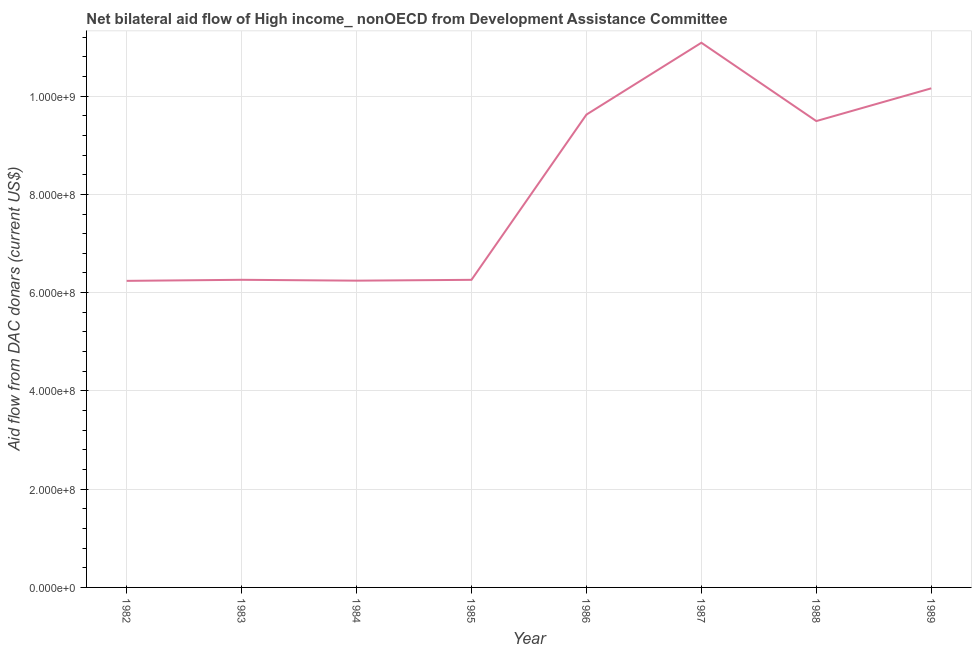What is the net bilateral aid flows from dac donors in 1988?
Give a very brief answer. 9.49e+08. Across all years, what is the maximum net bilateral aid flows from dac donors?
Provide a succinct answer. 1.11e+09. Across all years, what is the minimum net bilateral aid flows from dac donors?
Offer a very short reply. 6.24e+08. In which year was the net bilateral aid flows from dac donors maximum?
Your response must be concise. 1987. In which year was the net bilateral aid flows from dac donors minimum?
Offer a very short reply. 1982. What is the sum of the net bilateral aid flows from dac donors?
Your answer should be compact. 6.54e+09. What is the difference between the net bilateral aid flows from dac donors in 1986 and 1987?
Keep it short and to the point. -1.46e+08. What is the average net bilateral aid flows from dac donors per year?
Your response must be concise. 8.17e+08. What is the median net bilateral aid flows from dac donors?
Ensure brevity in your answer.  7.88e+08. What is the ratio of the net bilateral aid flows from dac donors in 1988 to that in 1989?
Provide a succinct answer. 0.93. Is the net bilateral aid flows from dac donors in 1982 less than that in 1983?
Your response must be concise. Yes. Is the difference between the net bilateral aid flows from dac donors in 1982 and 1989 greater than the difference between any two years?
Give a very brief answer. No. What is the difference between the highest and the second highest net bilateral aid flows from dac donors?
Offer a terse response. 9.28e+07. What is the difference between the highest and the lowest net bilateral aid flows from dac donors?
Give a very brief answer. 4.85e+08. In how many years, is the net bilateral aid flows from dac donors greater than the average net bilateral aid flows from dac donors taken over all years?
Your response must be concise. 4. How many years are there in the graph?
Provide a succinct answer. 8. What is the difference between two consecutive major ticks on the Y-axis?
Provide a short and direct response. 2.00e+08. Does the graph contain any zero values?
Keep it short and to the point. No. What is the title of the graph?
Ensure brevity in your answer.  Net bilateral aid flow of High income_ nonOECD from Development Assistance Committee. What is the label or title of the X-axis?
Your response must be concise. Year. What is the label or title of the Y-axis?
Ensure brevity in your answer.  Aid flow from DAC donars (current US$). What is the Aid flow from DAC donars (current US$) in 1982?
Make the answer very short. 6.24e+08. What is the Aid flow from DAC donars (current US$) of 1983?
Give a very brief answer. 6.26e+08. What is the Aid flow from DAC donars (current US$) of 1984?
Offer a very short reply. 6.24e+08. What is the Aid flow from DAC donars (current US$) in 1985?
Provide a succinct answer. 6.26e+08. What is the Aid flow from DAC donars (current US$) of 1986?
Keep it short and to the point. 9.62e+08. What is the Aid flow from DAC donars (current US$) of 1987?
Provide a short and direct response. 1.11e+09. What is the Aid flow from DAC donars (current US$) of 1988?
Provide a short and direct response. 9.49e+08. What is the Aid flow from DAC donars (current US$) in 1989?
Provide a short and direct response. 1.02e+09. What is the difference between the Aid flow from DAC donars (current US$) in 1982 and 1983?
Make the answer very short. -2.17e+06. What is the difference between the Aid flow from DAC donars (current US$) in 1982 and 1984?
Your response must be concise. -4.10e+05. What is the difference between the Aid flow from DAC donars (current US$) in 1982 and 1985?
Provide a succinct answer. -2.11e+06. What is the difference between the Aid flow from DAC donars (current US$) in 1982 and 1986?
Make the answer very short. -3.38e+08. What is the difference between the Aid flow from DAC donars (current US$) in 1982 and 1987?
Make the answer very short. -4.85e+08. What is the difference between the Aid flow from DAC donars (current US$) in 1982 and 1988?
Your answer should be compact. -3.25e+08. What is the difference between the Aid flow from DAC donars (current US$) in 1982 and 1989?
Provide a short and direct response. -3.92e+08. What is the difference between the Aid flow from DAC donars (current US$) in 1983 and 1984?
Your answer should be very brief. 1.76e+06. What is the difference between the Aid flow from DAC donars (current US$) in 1983 and 1986?
Your answer should be very brief. -3.36e+08. What is the difference between the Aid flow from DAC donars (current US$) in 1983 and 1987?
Your answer should be compact. -4.83e+08. What is the difference between the Aid flow from DAC donars (current US$) in 1983 and 1988?
Offer a terse response. -3.23e+08. What is the difference between the Aid flow from DAC donars (current US$) in 1983 and 1989?
Your answer should be very brief. -3.90e+08. What is the difference between the Aid flow from DAC donars (current US$) in 1984 and 1985?
Ensure brevity in your answer.  -1.70e+06. What is the difference between the Aid flow from DAC donars (current US$) in 1984 and 1986?
Offer a very short reply. -3.38e+08. What is the difference between the Aid flow from DAC donars (current US$) in 1984 and 1987?
Offer a very short reply. -4.84e+08. What is the difference between the Aid flow from DAC donars (current US$) in 1984 and 1988?
Provide a succinct answer. -3.25e+08. What is the difference between the Aid flow from DAC donars (current US$) in 1984 and 1989?
Provide a succinct answer. -3.91e+08. What is the difference between the Aid flow from DAC donars (current US$) in 1985 and 1986?
Offer a terse response. -3.36e+08. What is the difference between the Aid flow from DAC donars (current US$) in 1985 and 1987?
Provide a short and direct response. -4.83e+08. What is the difference between the Aid flow from DAC donars (current US$) in 1985 and 1988?
Offer a very short reply. -3.23e+08. What is the difference between the Aid flow from DAC donars (current US$) in 1985 and 1989?
Your answer should be compact. -3.90e+08. What is the difference between the Aid flow from DAC donars (current US$) in 1986 and 1987?
Your answer should be very brief. -1.46e+08. What is the difference between the Aid flow from DAC donars (current US$) in 1986 and 1988?
Your answer should be very brief. 1.32e+07. What is the difference between the Aid flow from DAC donars (current US$) in 1986 and 1989?
Your answer should be very brief. -5.35e+07. What is the difference between the Aid flow from DAC donars (current US$) in 1987 and 1988?
Provide a succinct answer. 1.59e+08. What is the difference between the Aid flow from DAC donars (current US$) in 1987 and 1989?
Your answer should be very brief. 9.28e+07. What is the difference between the Aid flow from DAC donars (current US$) in 1988 and 1989?
Your answer should be compact. -6.66e+07. What is the ratio of the Aid flow from DAC donars (current US$) in 1982 to that in 1983?
Your answer should be compact. 1. What is the ratio of the Aid flow from DAC donars (current US$) in 1982 to that in 1984?
Give a very brief answer. 1. What is the ratio of the Aid flow from DAC donars (current US$) in 1982 to that in 1986?
Offer a terse response. 0.65. What is the ratio of the Aid flow from DAC donars (current US$) in 1982 to that in 1987?
Your answer should be very brief. 0.56. What is the ratio of the Aid flow from DAC donars (current US$) in 1982 to that in 1988?
Offer a very short reply. 0.66. What is the ratio of the Aid flow from DAC donars (current US$) in 1982 to that in 1989?
Provide a succinct answer. 0.61. What is the ratio of the Aid flow from DAC donars (current US$) in 1983 to that in 1986?
Your response must be concise. 0.65. What is the ratio of the Aid flow from DAC donars (current US$) in 1983 to that in 1987?
Give a very brief answer. 0.56. What is the ratio of the Aid flow from DAC donars (current US$) in 1983 to that in 1988?
Offer a very short reply. 0.66. What is the ratio of the Aid flow from DAC donars (current US$) in 1983 to that in 1989?
Give a very brief answer. 0.62. What is the ratio of the Aid flow from DAC donars (current US$) in 1984 to that in 1985?
Keep it short and to the point. 1. What is the ratio of the Aid flow from DAC donars (current US$) in 1984 to that in 1986?
Offer a terse response. 0.65. What is the ratio of the Aid flow from DAC donars (current US$) in 1984 to that in 1987?
Make the answer very short. 0.56. What is the ratio of the Aid flow from DAC donars (current US$) in 1984 to that in 1988?
Provide a succinct answer. 0.66. What is the ratio of the Aid flow from DAC donars (current US$) in 1984 to that in 1989?
Your response must be concise. 0.61. What is the ratio of the Aid flow from DAC donars (current US$) in 1985 to that in 1986?
Give a very brief answer. 0.65. What is the ratio of the Aid flow from DAC donars (current US$) in 1985 to that in 1987?
Your answer should be very brief. 0.56. What is the ratio of the Aid flow from DAC donars (current US$) in 1985 to that in 1988?
Provide a short and direct response. 0.66. What is the ratio of the Aid flow from DAC donars (current US$) in 1985 to that in 1989?
Your answer should be very brief. 0.62. What is the ratio of the Aid flow from DAC donars (current US$) in 1986 to that in 1987?
Your answer should be very brief. 0.87. What is the ratio of the Aid flow from DAC donars (current US$) in 1986 to that in 1988?
Your answer should be compact. 1.01. What is the ratio of the Aid flow from DAC donars (current US$) in 1986 to that in 1989?
Your answer should be very brief. 0.95. What is the ratio of the Aid flow from DAC donars (current US$) in 1987 to that in 1988?
Offer a terse response. 1.17. What is the ratio of the Aid flow from DAC donars (current US$) in 1987 to that in 1989?
Your answer should be compact. 1.09. What is the ratio of the Aid flow from DAC donars (current US$) in 1988 to that in 1989?
Keep it short and to the point. 0.93. 